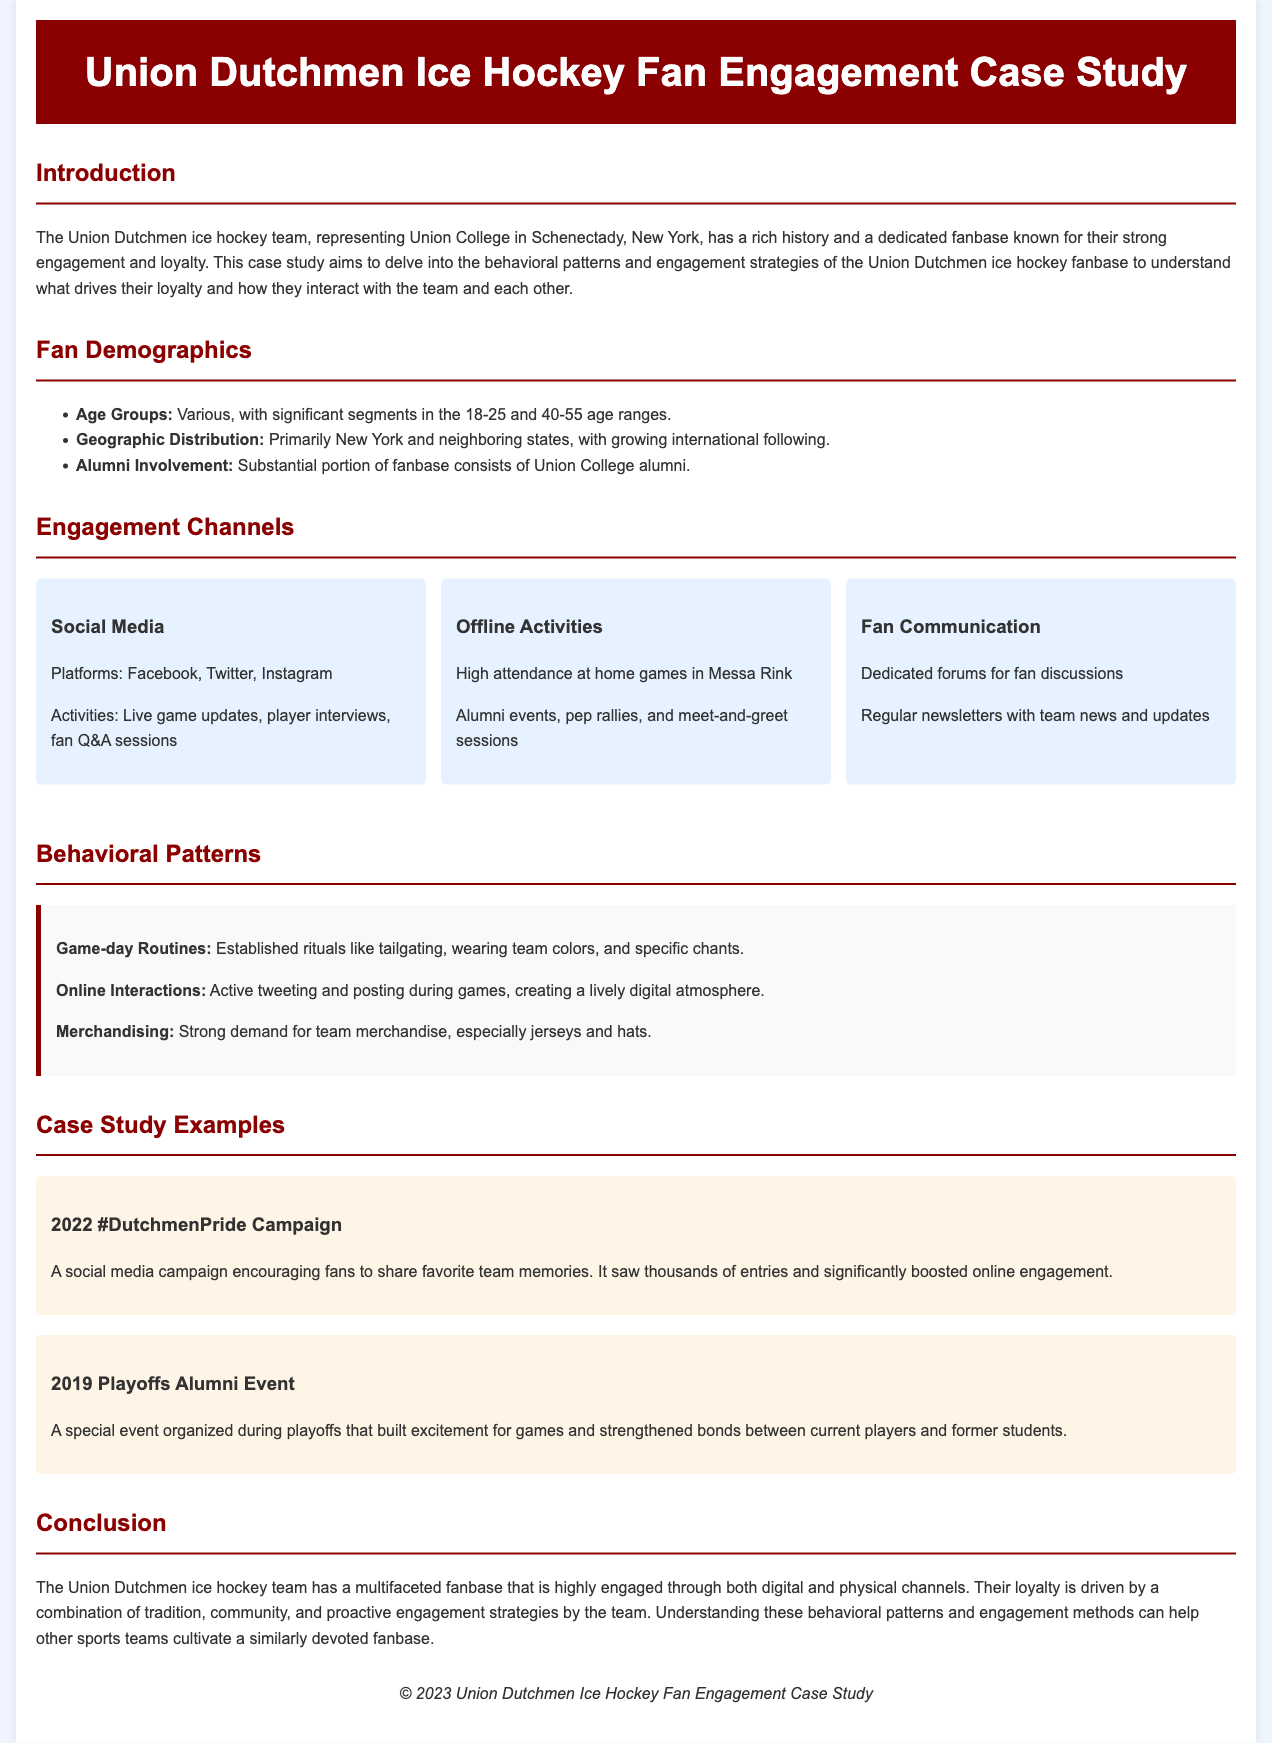What is the primary geographic distribution of the Union Dutchmen fanbase? The geographic distribution is primarily in New York and neighboring states, with a growing international following.
Answer: New York and neighboring states What are the key age groups of the fanbase? The key age groups are mentioned in the demographics section, highlighting significant segments.
Answer: 18-25 and 40-55 Name one platform used for fan communication. The document lists specific engagement channels, including social media and forums.
Answer: Dedicated forums What established game-day routine is mentioned in the behavioral patterns? The behavioral patterns section outlines several routines associated with game days.
Answer: Tailgating What was the outcome of the 2022 #DutchmenPride campaign? The campaign encouraged fans to share memories and resulted in thousands of entries and increased online engagement.
Answer: Thousands of entries What event was organized during the 2019 playoffs? An alumni event was organized to foster excitement during the playoffs.
Answer: Alumni Event How does the document categorize the fan engagement strategies? The document discusses engagement channels in different categories such as social media and offline activities.
Answer: Engagement channels What is a significant aspect of the Union Dutchmen fan loyalty? The document identifies several drivers of fan loyalty, emphasizing key elements contributing to this loyalty.
Answer: Tradition, community, engagement strategies 